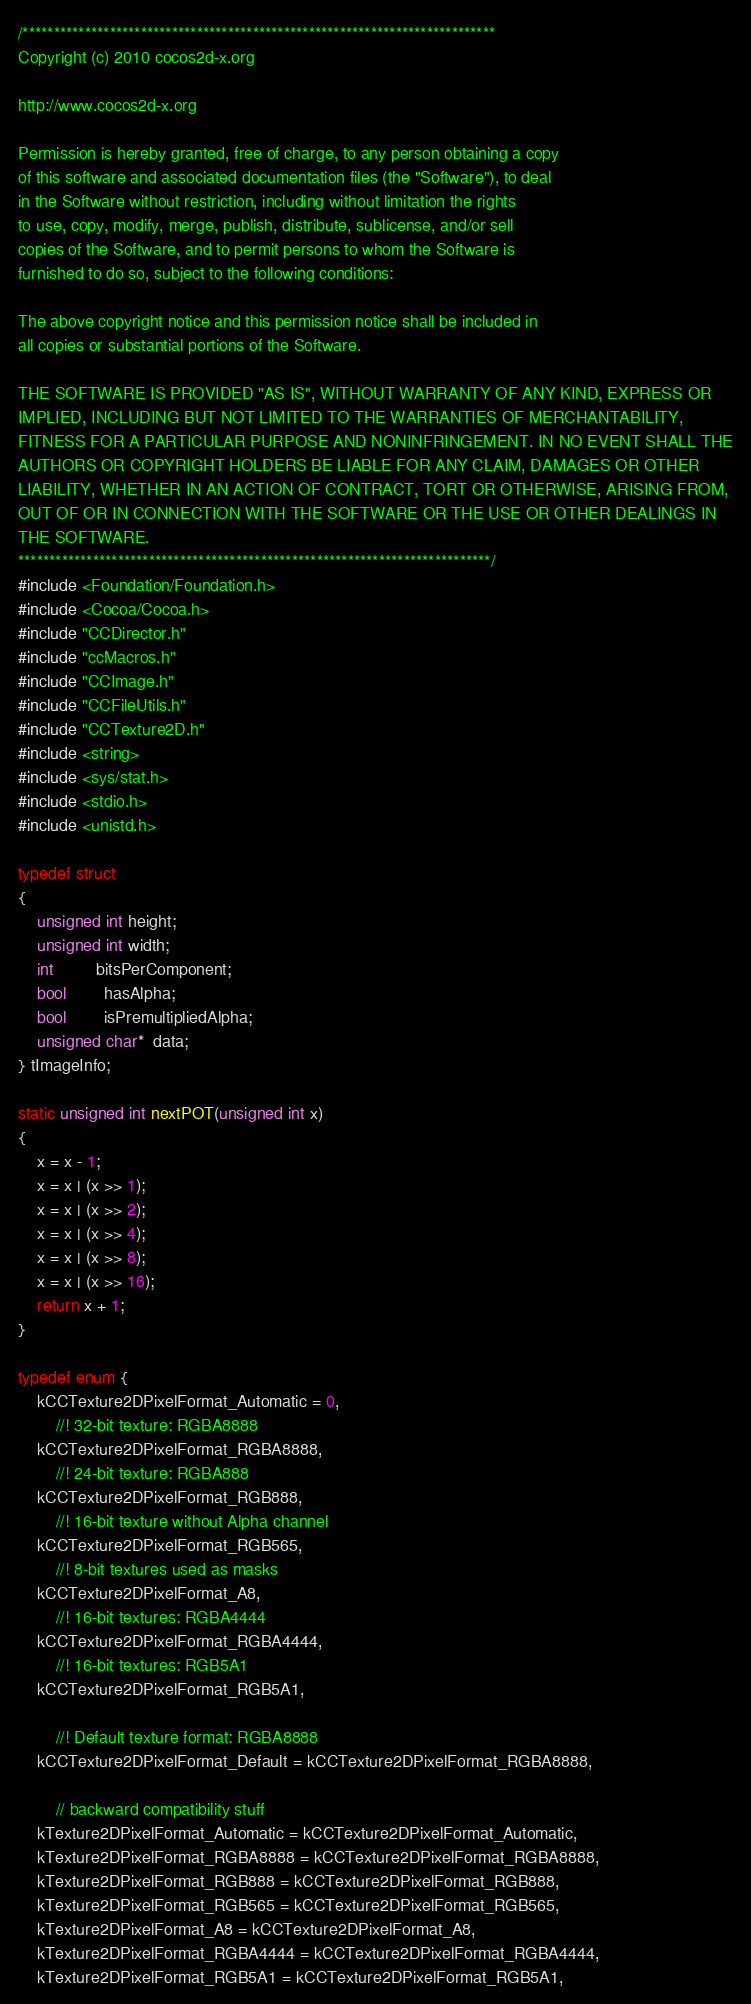Convert code to text. <code><loc_0><loc_0><loc_500><loc_500><_ObjectiveC_>/****************************************************************************
Copyright (c) 2010 cocos2d-x.org

http://www.cocos2d-x.org

Permission is hereby granted, free of charge, to any person obtaining a copy
of this software and associated documentation files (the "Software"), to deal
in the Software without restriction, including without limitation the rights
to use, copy, modify, merge, publish, distribute, sublicense, and/or sell
copies of the Software, and to permit persons to whom the Software is
furnished to do so, subject to the following conditions:

The above copyright notice and this permission notice shall be included in
all copies or substantial portions of the Software.

THE SOFTWARE IS PROVIDED "AS IS", WITHOUT WARRANTY OF ANY KIND, EXPRESS OR
IMPLIED, INCLUDING BUT NOT LIMITED TO THE WARRANTIES OF MERCHANTABILITY,
FITNESS FOR A PARTICULAR PURPOSE AND NONINFRINGEMENT. IN NO EVENT SHALL THE
AUTHORS OR COPYRIGHT HOLDERS BE LIABLE FOR ANY CLAIM, DAMAGES OR OTHER
LIABILITY, WHETHER IN AN ACTION OF CONTRACT, TORT OR OTHERWISE, ARISING FROM,
OUT OF OR IN CONNECTION WITH THE SOFTWARE OR THE USE OR OTHER DEALINGS IN
THE SOFTWARE.
****************************************************************************/
#include <Foundation/Foundation.h>
#include <Cocoa/Cocoa.h>
#include "CCDirector.h"
#include "ccMacros.h"
#include "CCImage.h"
#include "CCFileUtils.h"
#include "CCTexture2D.h"
#include <string>
#include <sys/stat.h>
#include <stdio.h>
#include <unistd.h>

typedef struct
{
    unsigned int height;
    unsigned int width;
    int         bitsPerComponent;
    bool        hasAlpha;
    bool        isPremultipliedAlpha;
    unsigned char*  data;
} tImageInfo;

static unsigned int nextPOT(unsigned int x)
{
    x = x - 1;
    x = x | (x >> 1);
    x = x | (x >> 2);
    x = x | (x >> 4);
    x = x | (x >> 8);
    x = x | (x >> 16);
    return x + 1;
}

typedef enum {
    kCCTexture2DPixelFormat_Automatic = 0,
        //! 32-bit texture: RGBA8888
    kCCTexture2DPixelFormat_RGBA8888,
        //! 24-bit texture: RGBA888
    kCCTexture2DPixelFormat_RGB888,
        //! 16-bit texture without Alpha channel
    kCCTexture2DPixelFormat_RGB565,
        //! 8-bit textures used as masks
    kCCTexture2DPixelFormat_A8,
        //! 16-bit textures: RGBA4444
    kCCTexture2DPixelFormat_RGBA4444,
        //! 16-bit textures: RGB5A1
    kCCTexture2DPixelFormat_RGB5A1,    
    
        //! Default texture format: RGBA8888
    kCCTexture2DPixelFormat_Default = kCCTexture2DPixelFormat_RGBA8888,
    
        // backward compatibility stuff
    kTexture2DPixelFormat_Automatic = kCCTexture2DPixelFormat_Automatic,
    kTexture2DPixelFormat_RGBA8888 = kCCTexture2DPixelFormat_RGBA8888,
    kTexture2DPixelFormat_RGB888 = kCCTexture2DPixelFormat_RGB888,
    kTexture2DPixelFormat_RGB565 = kCCTexture2DPixelFormat_RGB565,
    kTexture2DPixelFormat_A8 = kCCTexture2DPixelFormat_A8,
    kTexture2DPixelFormat_RGBA4444 = kCCTexture2DPixelFormat_RGBA4444,
    kTexture2DPixelFormat_RGB5A1 = kCCTexture2DPixelFormat_RGB5A1,</code> 